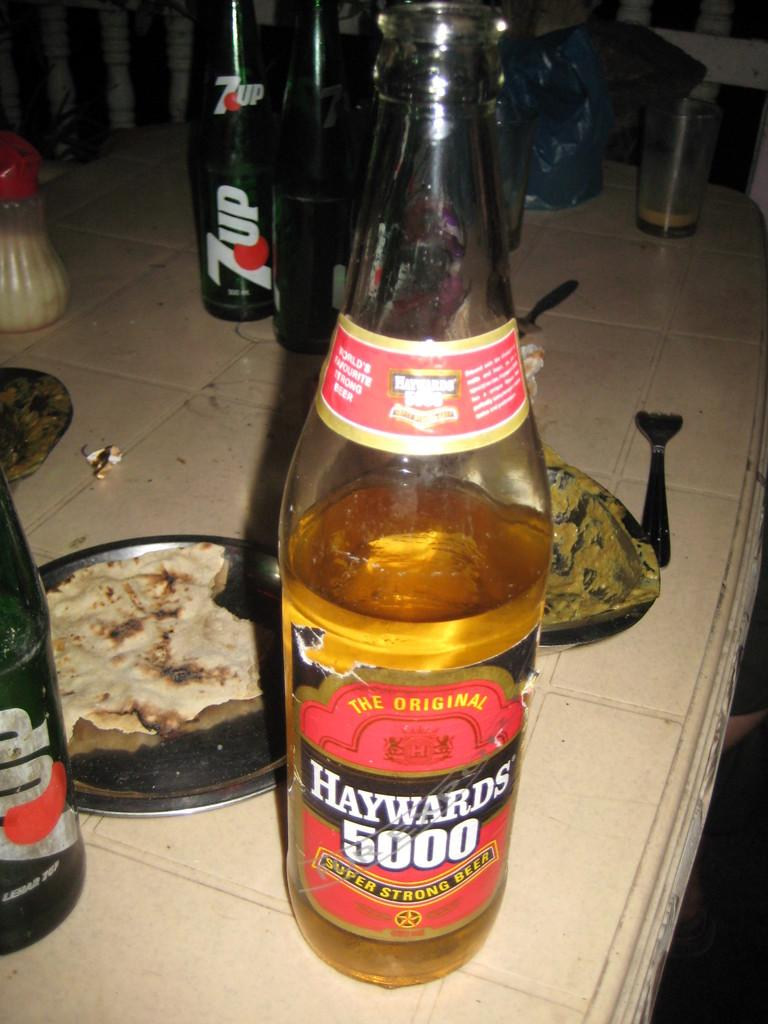Provide a one-sentence caption for the provided image. A dinner table with a bottle of Haywards 5000. 